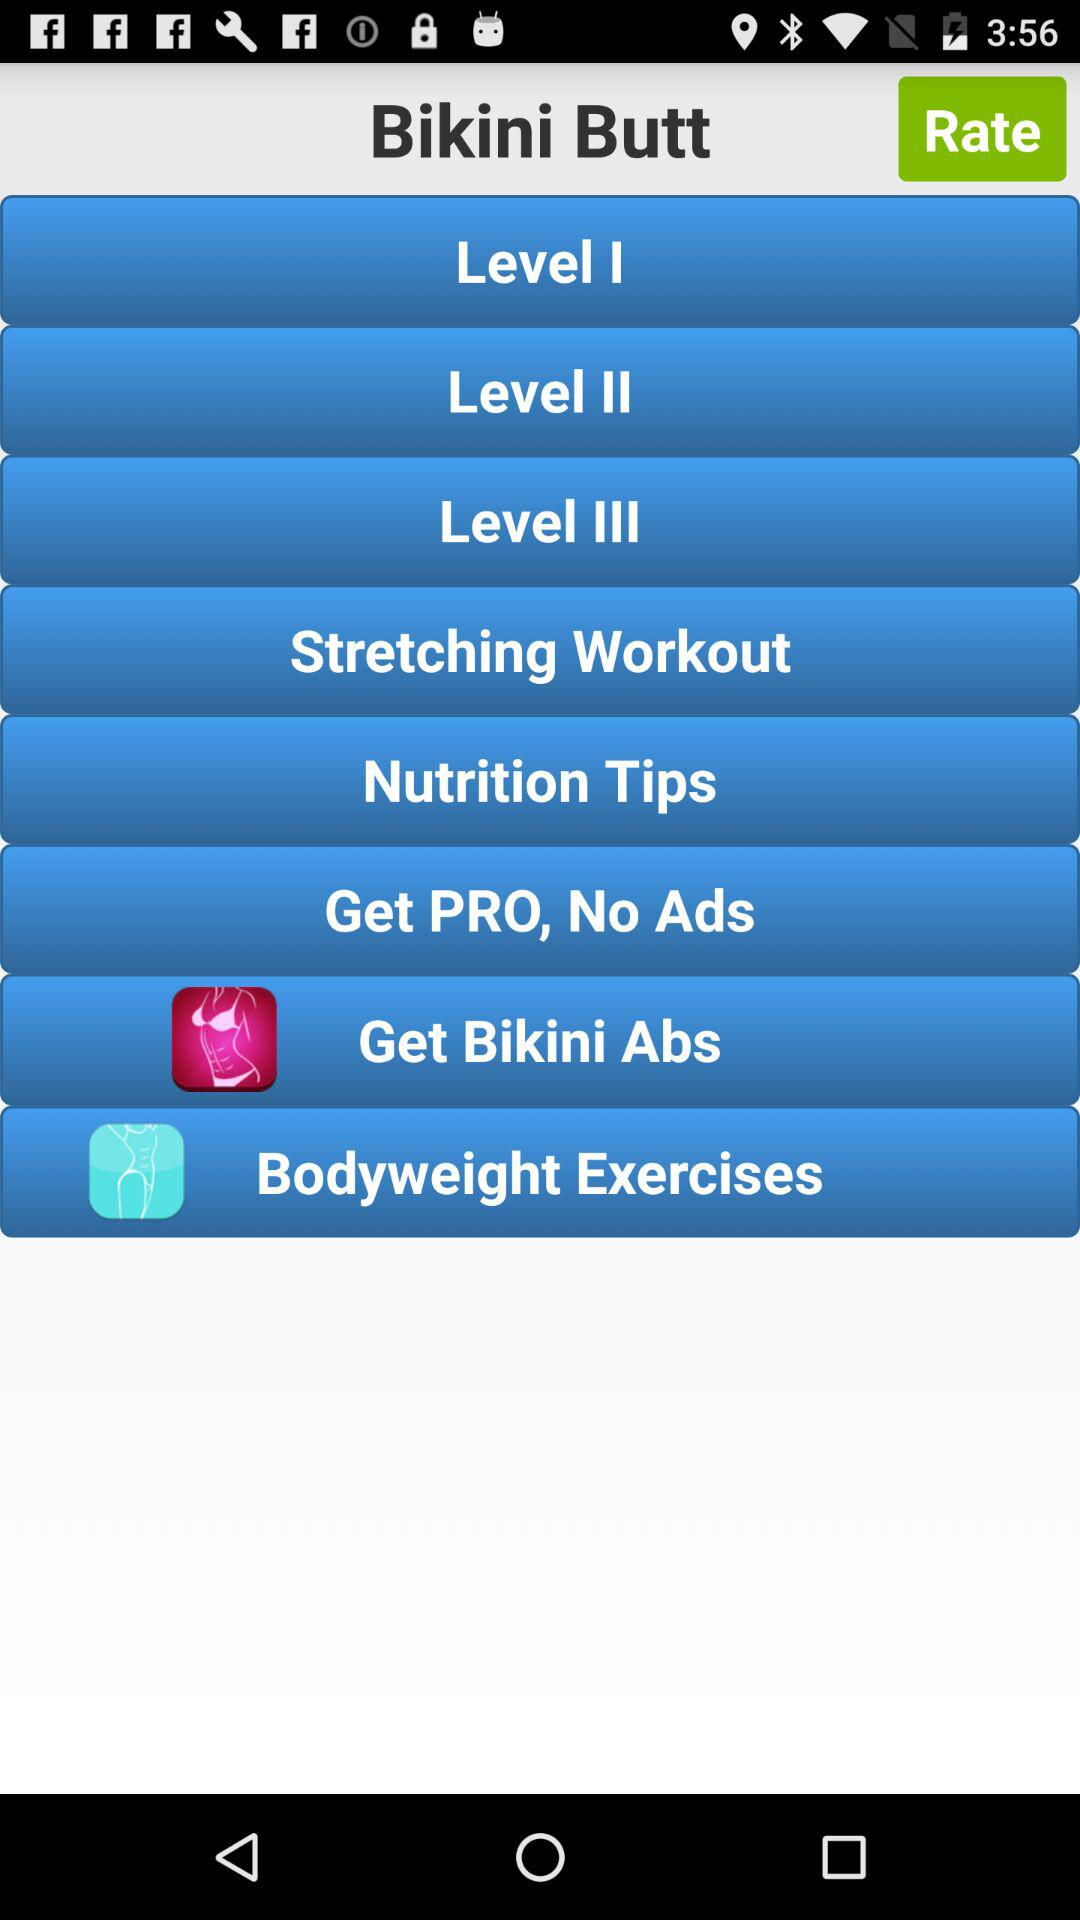What is the name of the application? The name of the application is "Bikini Butt". 